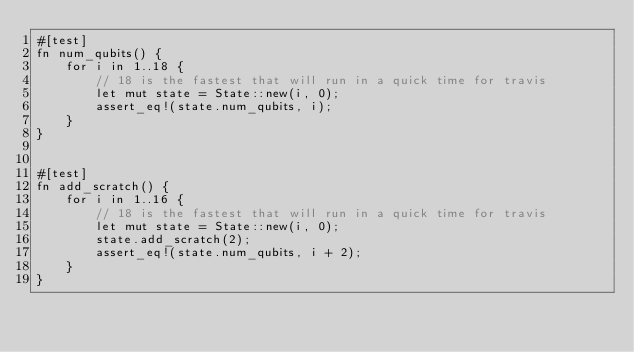Convert code to text. <code><loc_0><loc_0><loc_500><loc_500><_Rust_>#[test]
fn num_qubits() {
    for i in 1..18 {
        // 18 is the fastest that will run in a quick time for travis
        let mut state = State::new(i, 0);
        assert_eq!(state.num_qubits, i);
    }
}


#[test]
fn add_scratch() {
    for i in 1..16 {
        // 18 is the fastest that will run in a quick time for travis
        let mut state = State::new(i, 0);
        state.add_scratch(2);
        assert_eq!(state.num_qubits, i + 2);
    }
}

</code> 